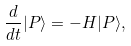<formula> <loc_0><loc_0><loc_500><loc_500>\frac { d } { d t } | P \rangle = - H | P \rangle ,</formula> 